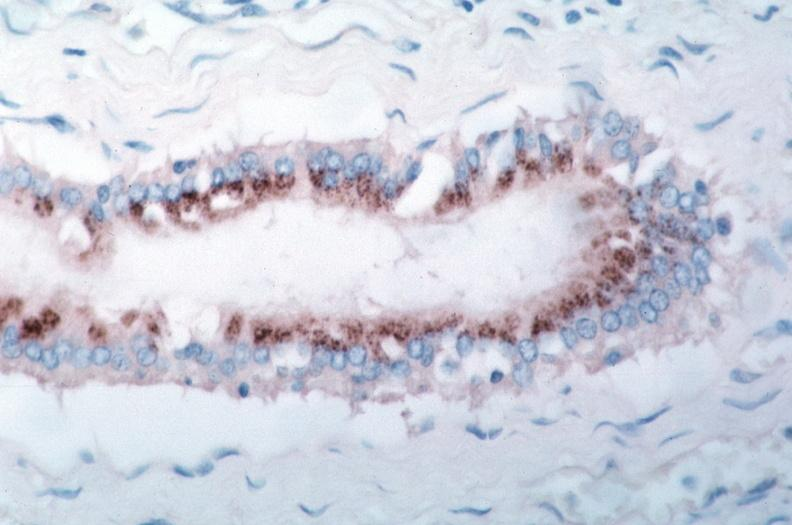what spotted fever , immunoperoxidase staining vessels for rickettsia rickettsii?
Answer the question using a single word or phrase. Vasculitis rocky mountain 